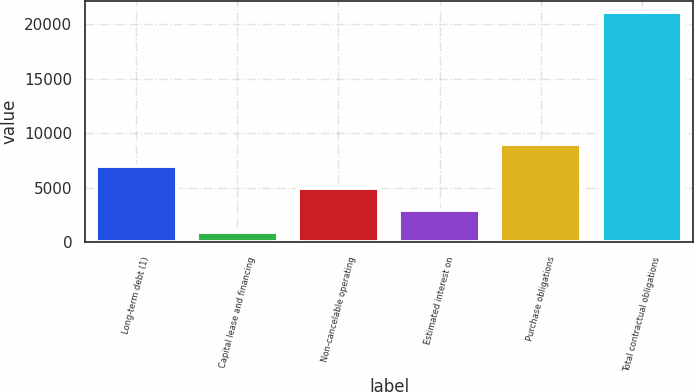Convert chart. <chart><loc_0><loc_0><loc_500><loc_500><bar_chart><fcel>Long-term debt (1)<fcel>Capital lease and financing<fcel>Non-cancelable operating<fcel>Estimated interest on<fcel>Purchase obligations<fcel>Total contractual obligations<nl><fcel>6979.1<fcel>917<fcel>4958.4<fcel>2937.7<fcel>8999.8<fcel>21124<nl></chart> 